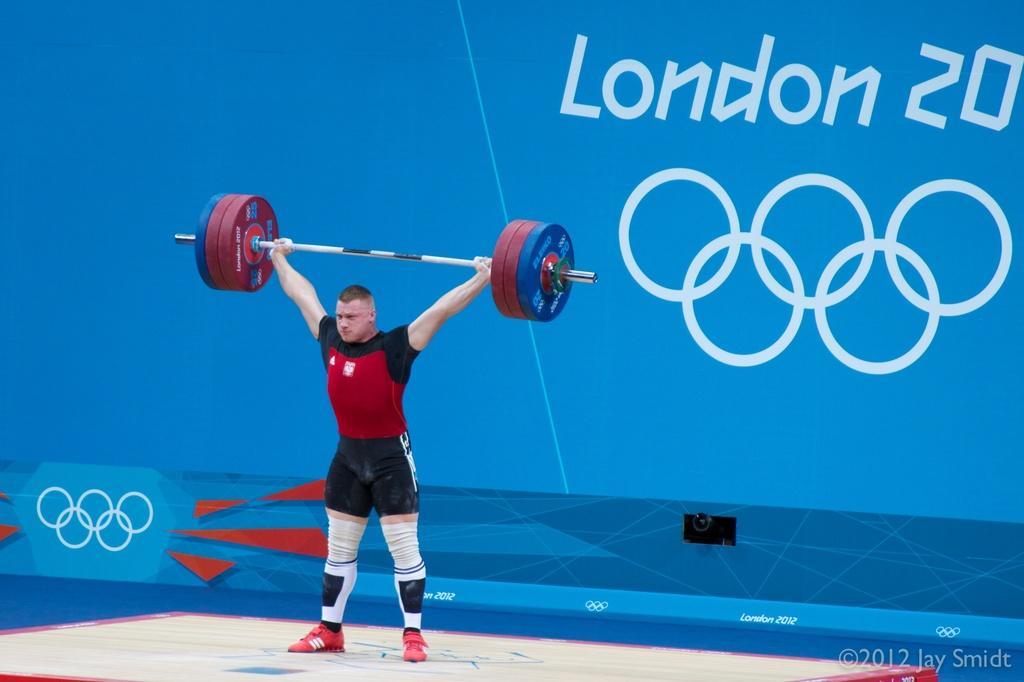Could you give a brief overview of what you see in this image? In this image we can see a man lifting weight and in the background there is a blue color wall with text and design on the wall. 